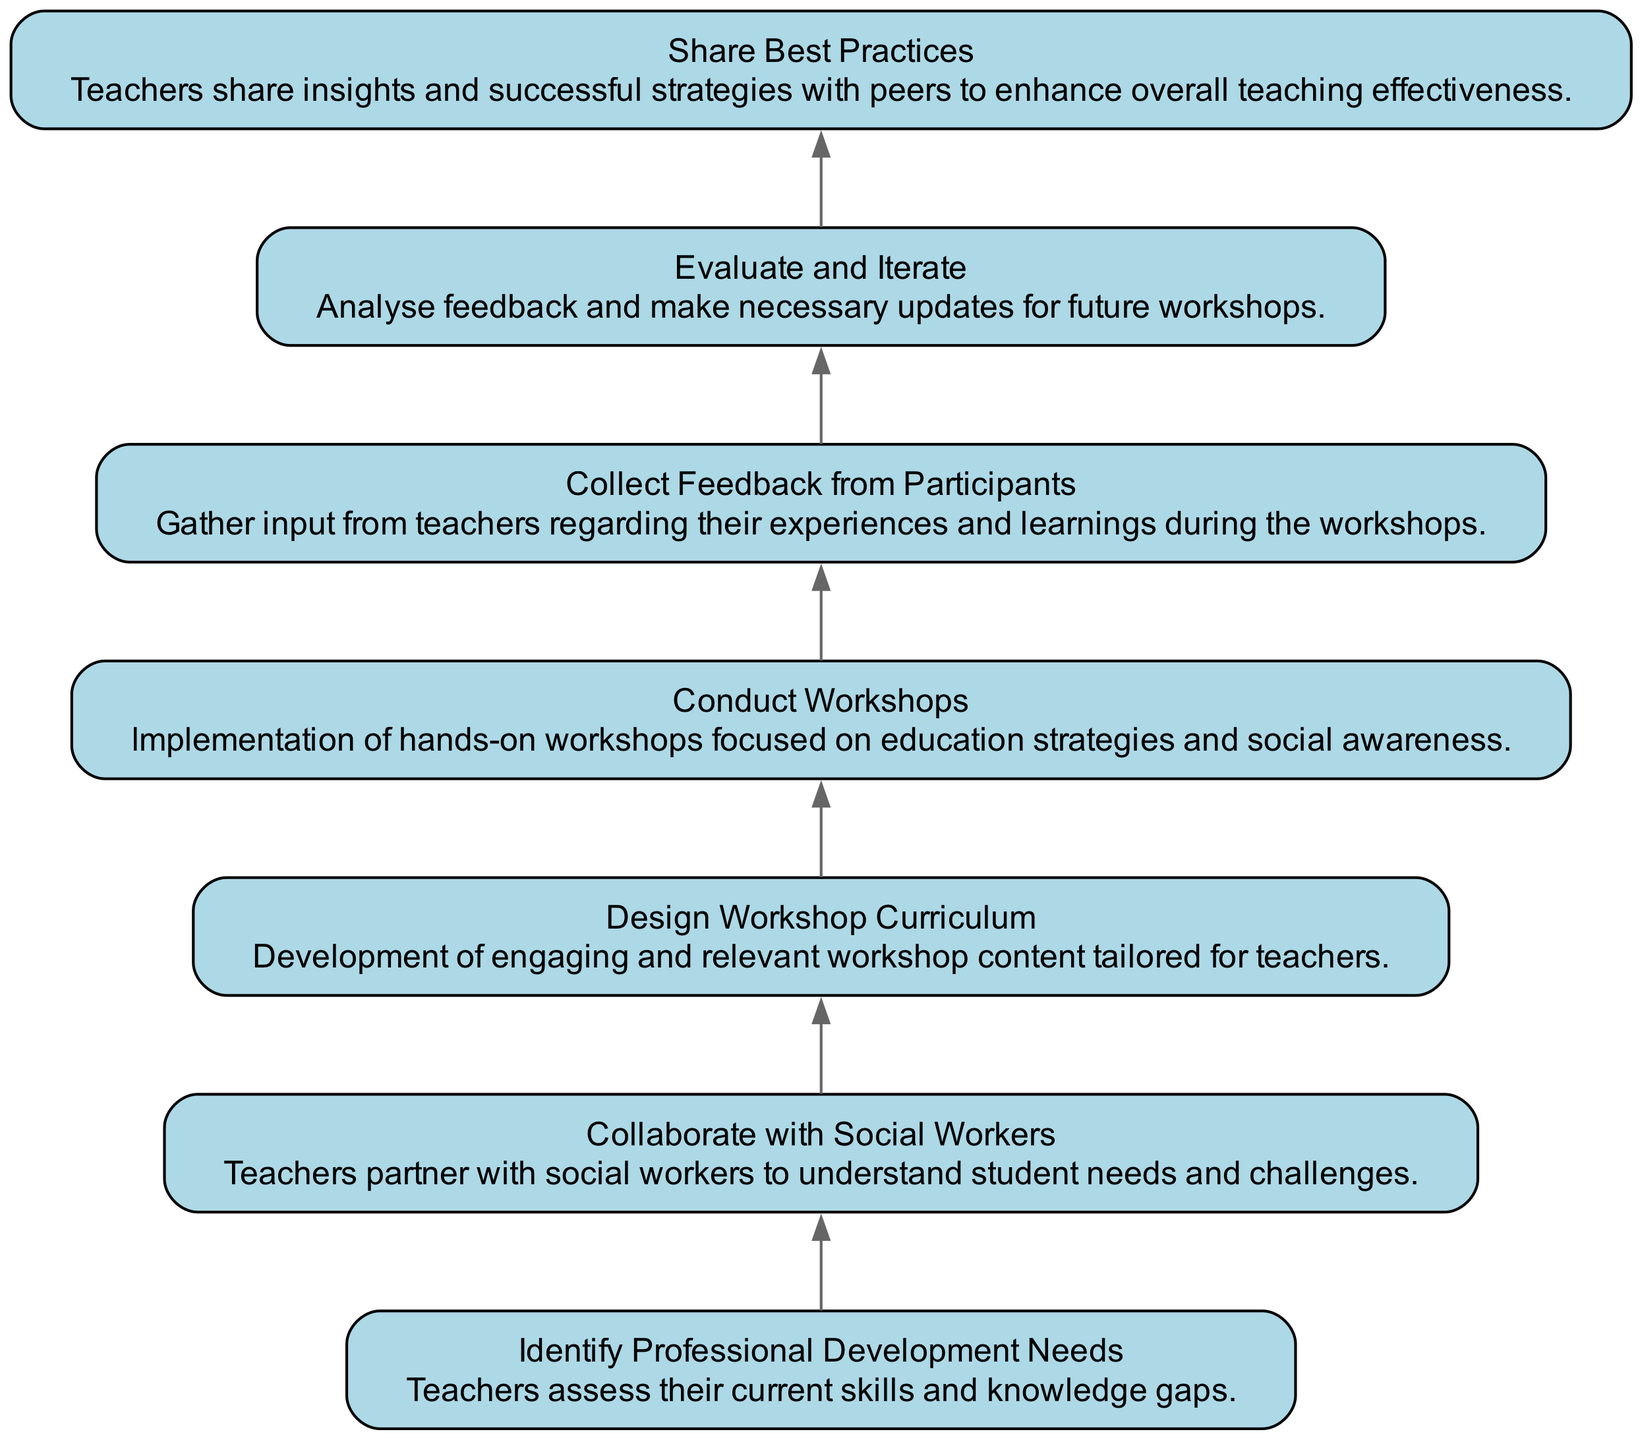What is the first step in the flow chart? The first step in the flow chart is "Identify Professional Development Needs." This can be identified by looking at the top node in the diagram, which initiates the sequence of actions.
Answer: Identify Professional Development Needs How many total nodes are there in the diagram? By counting each unique box or element displayed in the diagram, we find there are seven nodes in total.
Answer: 7 What is the relationship between "Conduct Workshops" and "Collect Feedback from Participants"? "Conduct Workshops" is directly connected to "Collect Feedback from Participants," indicating that feedback will be gathered immediately after the workshops are conducted.
Answer: Conduct Workshops → Collect Feedback from Participants What step follows after "Evaluate and Iterate"? The step that follows "Evaluate and Iterate" is "Share Best Practices." This progression is reflected in the directed flow of the diagram.
Answer: Share Best Practices Which node is at the end of the flow chart? The last node in the flow chart is "Share Best Practices," which signifies that it is the final result of the professional development process.
Answer: Share Best Practices What is the purpose of the node "Collaborate with Social Workers"? The purpose of "Collaborate with Social Workers" is to understand student needs and challenges, as indicated in the description of this node.
Answer: Understand student needs and challenges How does feedback influence future workshops? Feedback influences future workshops by being analyzed and used to make necessary updates, as depicted in the flow from "Collect Feedback from Participants" to "Evaluate and Iterate."
Answer: Necessary updates What type of chart is this diagram? This diagram is a "Bottom Up Flow Chart," which is specifically structured to illustrate a process that starts from the bottom and moves upward through several interconnected steps.
Answer: Bottom Up Flow Chart 